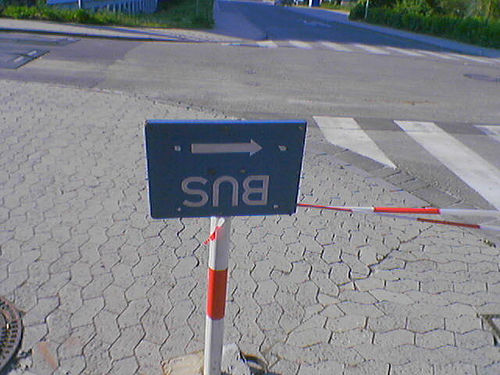Identify the text contained in this image. BUS 